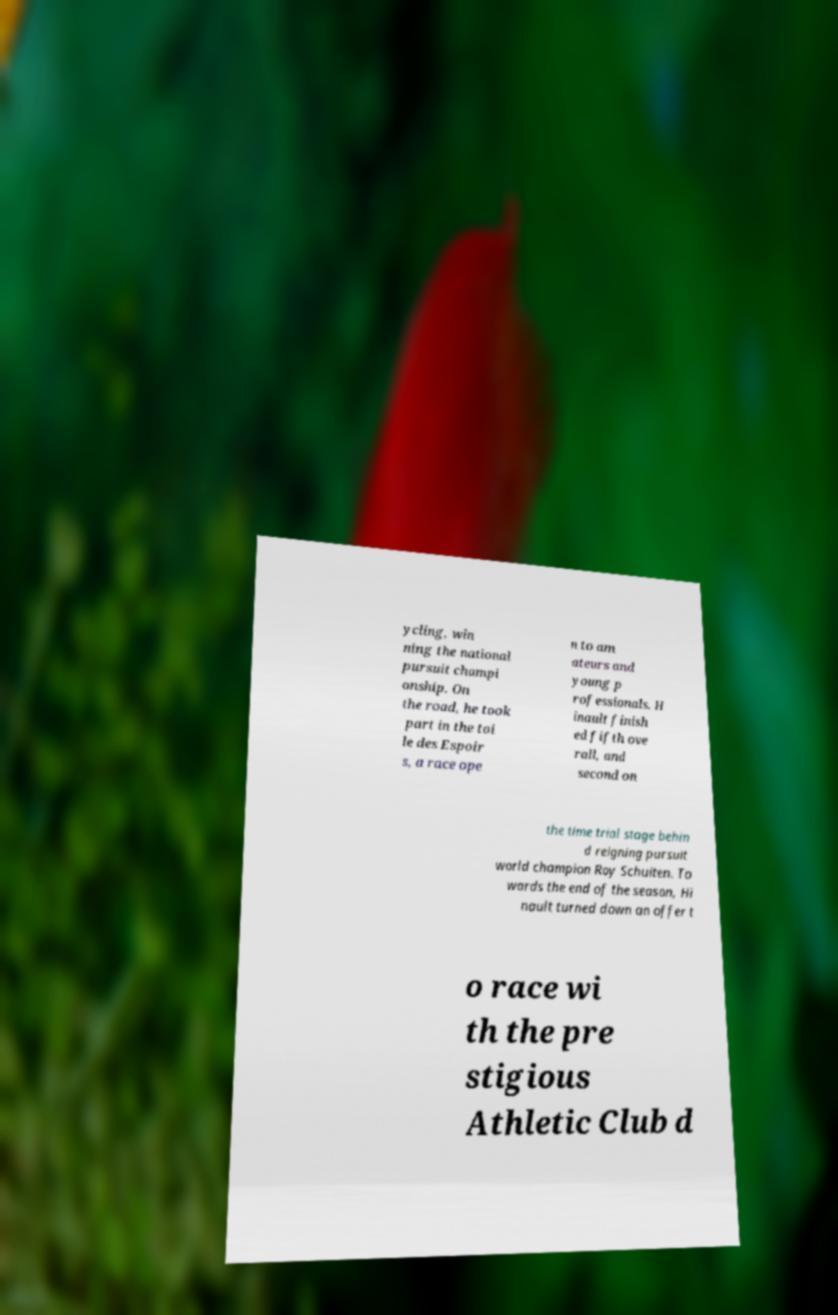For documentation purposes, I need the text within this image transcribed. Could you provide that? ycling, win ning the national pursuit champi onship. On the road, he took part in the toi le des Espoir s, a race ope n to am ateurs and young p rofessionals. H inault finish ed fifth ove rall, and second on the time trial stage behin d reigning pursuit world champion Roy Schuiten. To wards the end of the season, Hi nault turned down an offer t o race wi th the pre stigious Athletic Club d 